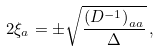Convert formula to latex. <formula><loc_0><loc_0><loc_500><loc_500>2 \xi _ { a } = \pm \sqrt { \frac { \left ( D ^ { - 1 } \right ) _ { a a } } { \Delta } } \, ,</formula> 